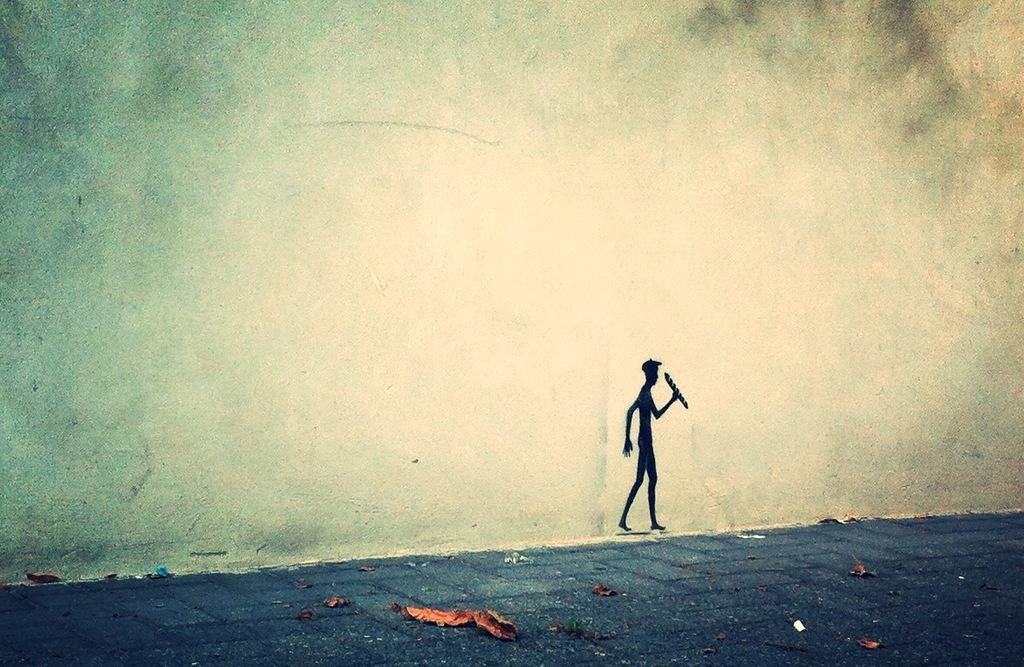What is depicted on the wall in the image? There is a painting of a person on a wall in the image. What can be seen on the ground in the image? There are dried leaves on the ground in the image. What account number is associated with the church in the image? There is no church or account number present in the image. How many people are visible in the image? The provided facts do not mention the number of people in the image, so we cannot definitively answer this question. 